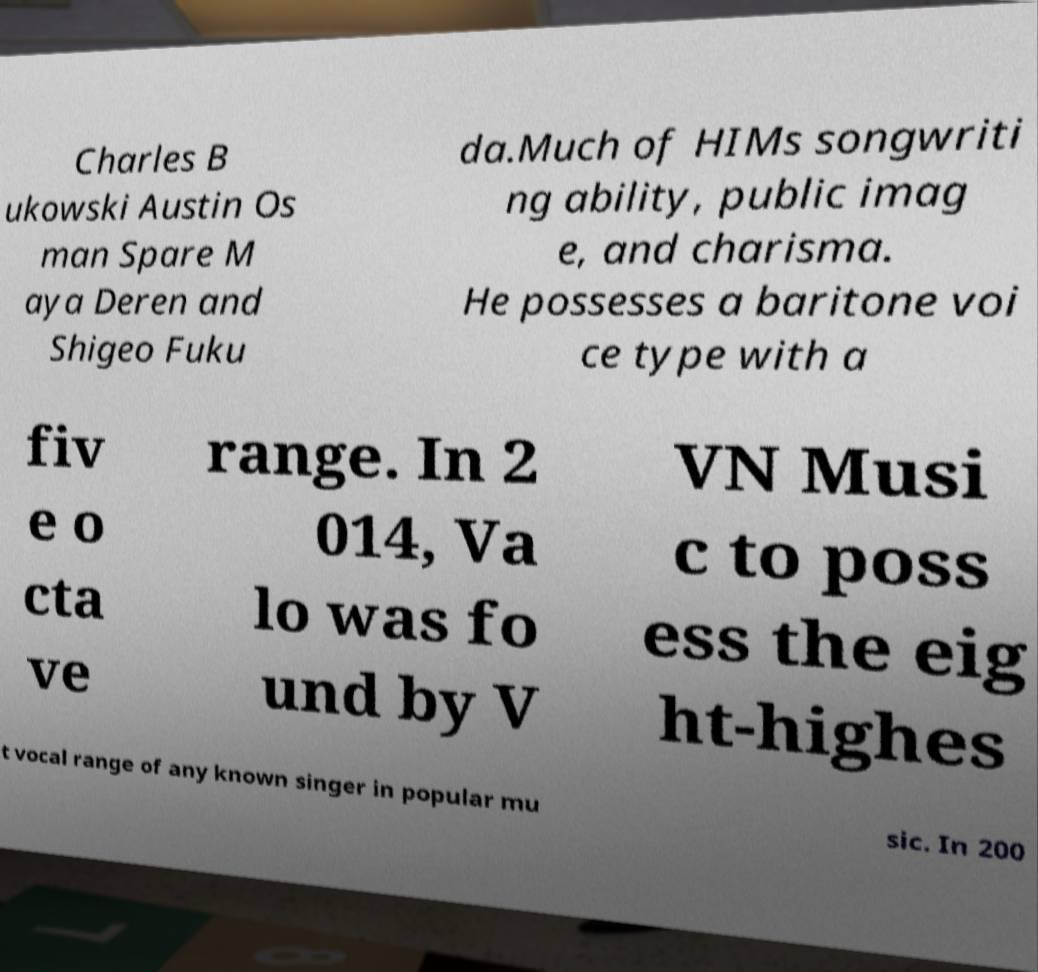For documentation purposes, I need the text within this image transcribed. Could you provide that? Charles B ukowski Austin Os man Spare M aya Deren and Shigeo Fuku da.Much of HIMs songwriti ng ability, public imag e, and charisma. He possesses a baritone voi ce type with a fiv e o cta ve range. In 2 014, Va lo was fo und by V VN Musi c to poss ess the eig ht-highes t vocal range of any known singer in popular mu sic. In 200 